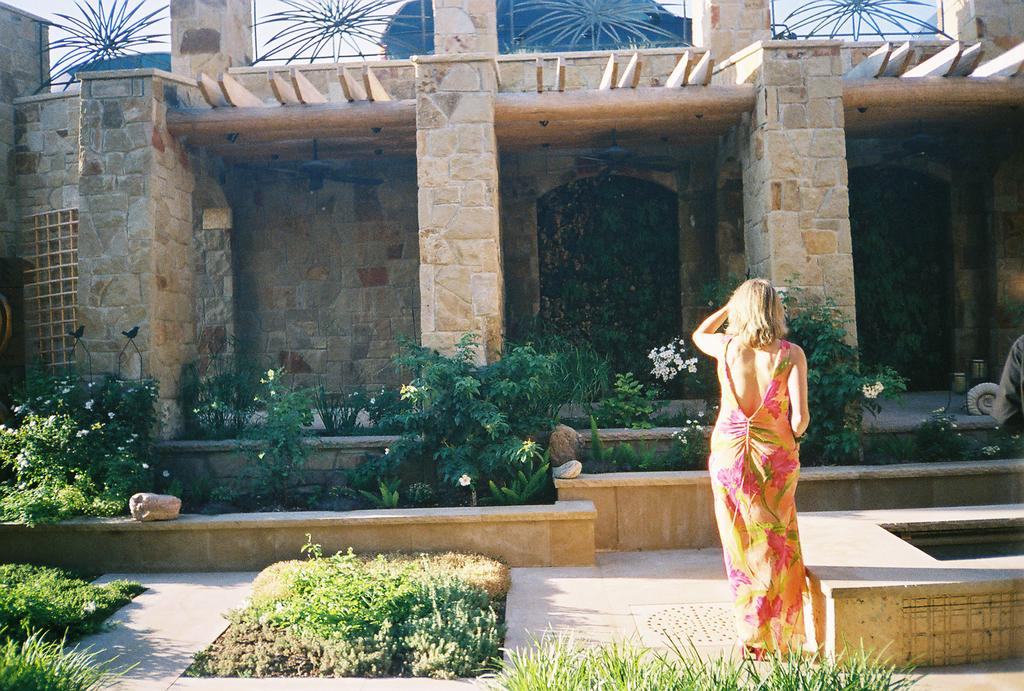What type of structure is present in the image? There is a building in the image. What can be seen growing near the building? There are plants in the image. What architectural feature is present in the image? There are pillars in the image. What type of flora is present in the image? There are flowers in the image. What type of barrier is present in the image? There is a grille in the image. What type of natural material is present in the image? There are stones in the image. Who is present in the image? There is a woman in the image. What is visible in the background of the image? The sky is visible in the image. How many legs can be seen on the woman in the image? The image does not show the woman's legs, so it is not possible to determine how many legs she has. What type of fingerprint can be seen on the grille in the image? There is no fingerprint visible on the grille in the image. 